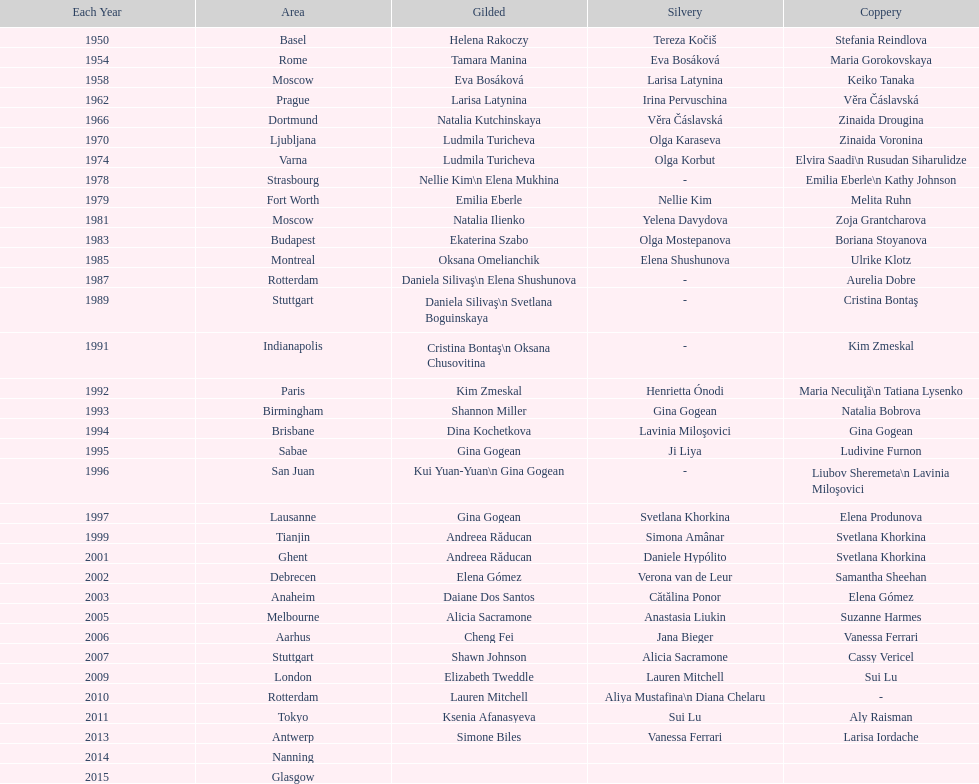How many consecutive floor exercise gold medals did romanian star andreea raducan win at the world championships? 2. 